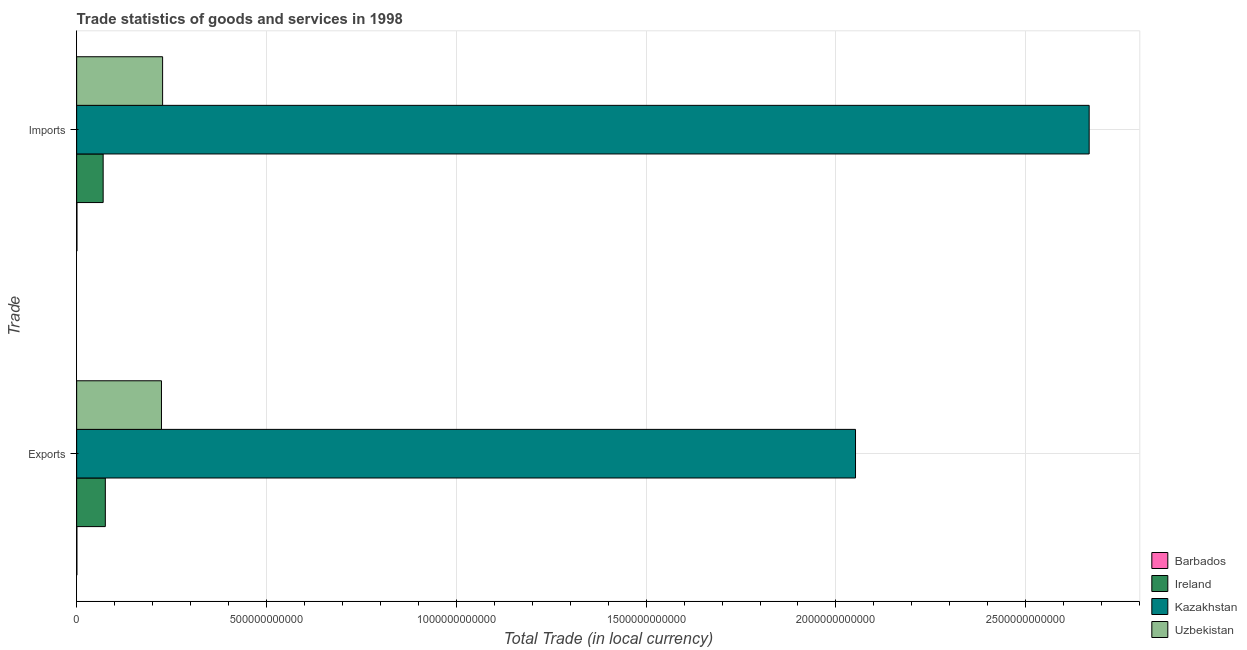How many different coloured bars are there?
Provide a succinct answer. 4. How many groups of bars are there?
Offer a terse response. 2. How many bars are there on the 2nd tick from the top?
Give a very brief answer. 4. How many bars are there on the 1st tick from the bottom?
Your response must be concise. 4. What is the label of the 2nd group of bars from the top?
Your response must be concise. Exports. What is the imports of goods and services in Barbados?
Keep it short and to the point. 7.89e+08. Across all countries, what is the maximum imports of goods and services?
Give a very brief answer. 2.67e+12. Across all countries, what is the minimum export of goods and services?
Give a very brief answer. 5.89e+08. In which country was the imports of goods and services maximum?
Your answer should be compact. Kazakhstan. In which country was the export of goods and services minimum?
Your answer should be compact. Barbados. What is the total imports of goods and services in the graph?
Give a very brief answer. 2.96e+12. What is the difference between the imports of goods and services in Uzbekistan and that in Barbados?
Make the answer very short. 2.26e+11. What is the difference between the export of goods and services in Kazakhstan and the imports of goods and services in Ireland?
Keep it short and to the point. 1.98e+12. What is the average export of goods and services per country?
Your answer should be very brief. 5.88e+11. What is the difference between the imports of goods and services and export of goods and services in Ireland?
Offer a terse response. -5.71e+09. What is the ratio of the imports of goods and services in Uzbekistan to that in Kazakhstan?
Provide a short and direct response. 0.08. What does the 2nd bar from the top in Imports represents?
Your answer should be very brief. Kazakhstan. What does the 2nd bar from the bottom in Exports represents?
Your response must be concise. Ireland. What is the difference between two consecutive major ticks on the X-axis?
Give a very brief answer. 5.00e+11. Are the values on the major ticks of X-axis written in scientific E-notation?
Provide a short and direct response. No. Does the graph contain grids?
Offer a terse response. Yes. Where does the legend appear in the graph?
Your answer should be very brief. Bottom right. What is the title of the graph?
Provide a succinct answer. Trade statistics of goods and services in 1998. Does "Marshall Islands" appear as one of the legend labels in the graph?
Keep it short and to the point. No. What is the label or title of the X-axis?
Ensure brevity in your answer.  Total Trade (in local currency). What is the label or title of the Y-axis?
Offer a very short reply. Trade. What is the Total Trade (in local currency) in Barbados in Exports?
Make the answer very short. 5.89e+08. What is the Total Trade (in local currency) in Ireland in Exports?
Your answer should be compact. 7.55e+1. What is the Total Trade (in local currency) in Kazakhstan in Exports?
Your response must be concise. 2.05e+12. What is the Total Trade (in local currency) of Uzbekistan in Exports?
Your answer should be compact. 2.23e+11. What is the Total Trade (in local currency) in Barbados in Imports?
Make the answer very short. 7.89e+08. What is the Total Trade (in local currency) in Ireland in Imports?
Provide a short and direct response. 6.98e+1. What is the Total Trade (in local currency) in Kazakhstan in Imports?
Keep it short and to the point. 2.67e+12. What is the Total Trade (in local currency) of Uzbekistan in Imports?
Give a very brief answer. 2.26e+11. Across all Trade, what is the maximum Total Trade (in local currency) in Barbados?
Your answer should be compact. 7.89e+08. Across all Trade, what is the maximum Total Trade (in local currency) in Ireland?
Offer a terse response. 7.55e+1. Across all Trade, what is the maximum Total Trade (in local currency) in Kazakhstan?
Offer a very short reply. 2.67e+12. Across all Trade, what is the maximum Total Trade (in local currency) in Uzbekistan?
Ensure brevity in your answer.  2.26e+11. Across all Trade, what is the minimum Total Trade (in local currency) in Barbados?
Ensure brevity in your answer.  5.89e+08. Across all Trade, what is the minimum Total Trade (in local currency) in Ireland?
Keep it short and to the point. 6.98e+1. Across all Trade, what is the minimum Total Trade (in local currency) in Kazakhstan?
Keep it short and to the point. 2.05e+12. Across all Trade, what is the minimum Total Trade (in local currency) in Uzbekistan?
Your answer should be very brief. 2.23e+11. What is the total Total Trade (in local currency) in Barbados in the graph?
Your answer should be very brief. 1.38e+09. What is the total Total Trade (in local currency) of Ireland in the graph?
Make the answer very short. 1.45e+11. What is the total Total Trade (in local currency) of Kazakhstan in the graph?
Your answer should be very brief. 4.72e+12. What is the total Total Trade (in local currency) in Uzbekistan in the graph?
Offer a very short reply. 4.50e+11. What is the difference between the Total Trade (in local currency) in Barbados in Exports and that in Imports?
Keep it short and to the point. -2.00e+08. What is the difference between the Total Trade (in local currency) in Ireland in Exports and that in Imports?
Offer a very short reply. 5.71e+09. What is the difference between the Total Trade (in local currency) of Kazakhstan in Exports and that in Imports?
Offer a terse response. -6.15e+11. What is the difference between the Total Trade (in local currency) in Uzbekistan in Exports and that in Imports?
Provide a succinct answer. -2.98e+09. What is the difference between the Total Trade (in local currency) in Barbados in Exports and the Total Trade (in local currency) in Ireland in Imports?
Provide a short and direct response. -6.92e+1. What is the difference between the Total Trade (in local currency) of Barbados in Exports and the Total Trade (in local currency) of Kazakhstan in Imports?
Ensure brevity in your answer.  -2.67e+12. What is the difference between the Total Trade (in local currency) of Barbados in Exports and the Total Trade (in local currency) of Uzbekistan in Imports?
Offer a very short reply. -2.26e+11. What is the difference between the Total Trade (in local currency) in Ireland in Exports and the Total Trade (in local currency) in Kazakhstan in Imports?
Offer a terse response. -2.59e+12. What is the difference between the Total Trade (in local currency) in Ireland in Exports and the Total Trade (in local currency) in Uzbekistan in Imports?
Provide a succinct answer. -1.51e+11. What is the difference between the Total Trade (in local currency) of Kazakhstan in Exports and the Total Trade (in local currency) of Uzbekistan in Imports?
Your response must be concise. 1.83e+12. What is the average Total Trade (in local currency) of Barbados per Trade?
Offer a terse response. 6.89e+08. What is the average Total Trade (in local currency) in Ireland per Trade?
Keep it short and to the point. 7.26e+1. What is the average Total Trade (in local currency) in Kazakhstan per Trade?
Provide a succinct answer. 2.36e+12. What is the average Total Trade (in local currency) of Uzbekistan per Trade?
Ensure brevity in your answer.  2.25e+11. What is the difference between the Total Trade (in local currency) of Barbados and Total Trade (in local currency) of Ireland in Exports?
Make the answer very short. -7.49e+1. What is the difference between the Total Trade (in local currency) of Barbados and Total Trade (in local currency) of Kazakhstan in Exports?
Your answer should be compact. -2.05e+12. What is the difference between the Total Trade (in local currency) of Barbados and Total Trade (in local currency) of Uzbekistan in Exports?
Your answer should be compact. -2.23e+11. What is the difference between the Total Trade (in local currency) in Ireland and Total Trade (in local currency) in Kazakhstan in Exports?
Ensure brevity in your answer.  -1.98e+12. What is the difference between the Total Trade (in local currency) of Ireland and Total Trade (in local currency) of Uzbekistan in Exports?
Give a very brief answer. -1.48e+11. What is the difference between the Total Trade (in local currency) of Kazakhstan and Total Trade (in local currency) of Uzbekistan in Exports?
Ensure brevity in your answer.  1.83e+12. What is the difference between the Total Trade (in local currency) in Barbados and Total Trade (in local currency) in Ireland in Imports?
Provide a succinct answer. -6.90e+1. What is the difference between the Total Trade (in local currency) in Barbados and Total Trade (in local currency) in Kazakhstan in Imports?
Offer a terse response. -2.67e+12. What is the difference between the Total Trade (in local currency) of Barbados and Total Trade (in local currency) of Uzbekistan in Imports?
Make the answer very short. -2.26e+11. What is the difference between the Total Trade (in local currency) in Ireland and Total Trade (in local currency) in Kazakhstan in Imports?
Your answer should be compact. -2.60e+12. What is the difference between the Total Trade (in local currency) in Ireland and Total Trade (in local currency) in Uzbekistan in Imports?
Your answer should be very brief. -1.57e+11. What is the difference between the Total Trade (in local currency) of Kazakhstan and Total Trade (in local currency) of Uzbekistan in Imports?
Your response must be concise. 2.44e+12. What is the ratio of the Total Trade (in local currency) of Barbados in Exports to that in Imports?
Your response must be concise. 0.75. What is the ratio of the Total Trade (in local currency) of Ireland in Exports to that in Imports?
Make the answer very short. 1.08. What is the ratio of the Total Trade (in local currency) of Kazakhstan in Exports to that in Imports?
Provide a short and direct response. 0.77. What is the ratio of the Total Trade (in local currency) of Uzbekistan in Exports to that in Imports?
Offer a terse response. 0.99. What is the difference between the highest and the second highest Total Trade (in local currency) in Barbados?
Ensure brevity in your answer.  2.00e+08. What is the difference between the highest and the second highest Total Trade (in local currency) of Ireland?
Your answer should be very brief. 5.71e+09. What is the difference between the highest and the second highest Total Trade (in local currency) of Kazakhstan?
Your answer should be very brief. 6.15e+11. What is the difference between the highest and the second highest Total Trade (in local currency) in Uzbekistan?
Ensure brevity in your answer.  2.98e+09. What is the difference between the highest and the lowest Total Trade (in local currency) in Ireland?
Offer a terse response. 5.71e+09. What is the difference between the highest and the lowest Total Trade (in local currency) in Kazakhstan?
Ensure brevity in your answer.  6.15e+11. What is the difference between the highest and the lowest Total Trade (in local currency) in Uzbekistan?
Your answer should be compact. 2.98e+09. 